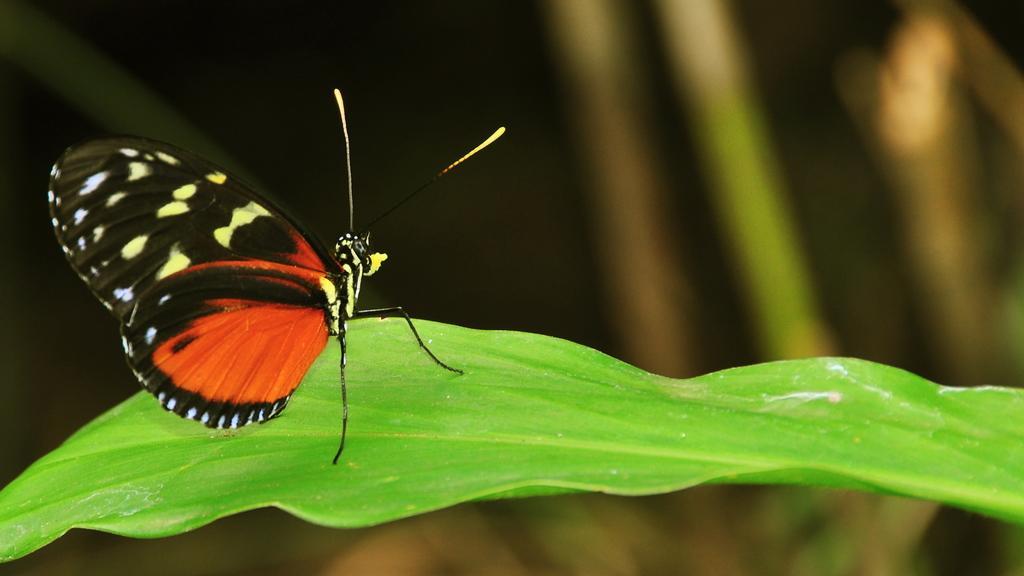Can you describe this image briefly? In this image I can see there is a butterfly sitting on the leaf and it has colorful wings, the backdrop of the image is blurred. 